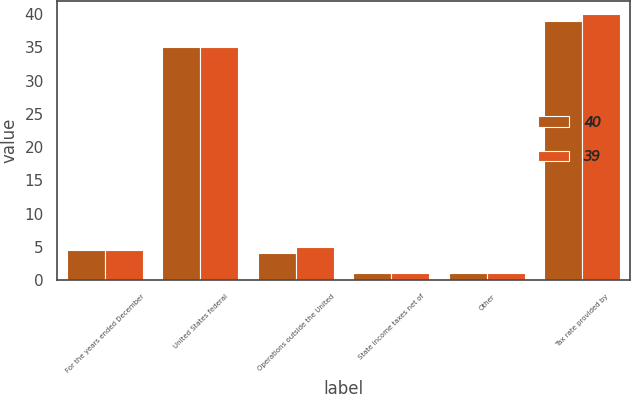Convert chart. <chart><loc_0><loc_0><loc_500><loc_500><stacked_bar_chart><ecel><fcel>For the years ended December<fcel>United States federal<fcel>Operations outside the United<fcel>State income taxes net of<fcel>Other<fcel>Tax rate provided by<nl><fcel>40<fcel>4.5<fcel>35<fcel>4<fcel>1<fcel>1<fcel>39<nl><fcel>39<fcel>4.5<fcel>35<fcel>5<fcel>1<fcel>1<fcel>40<nl></chart> 